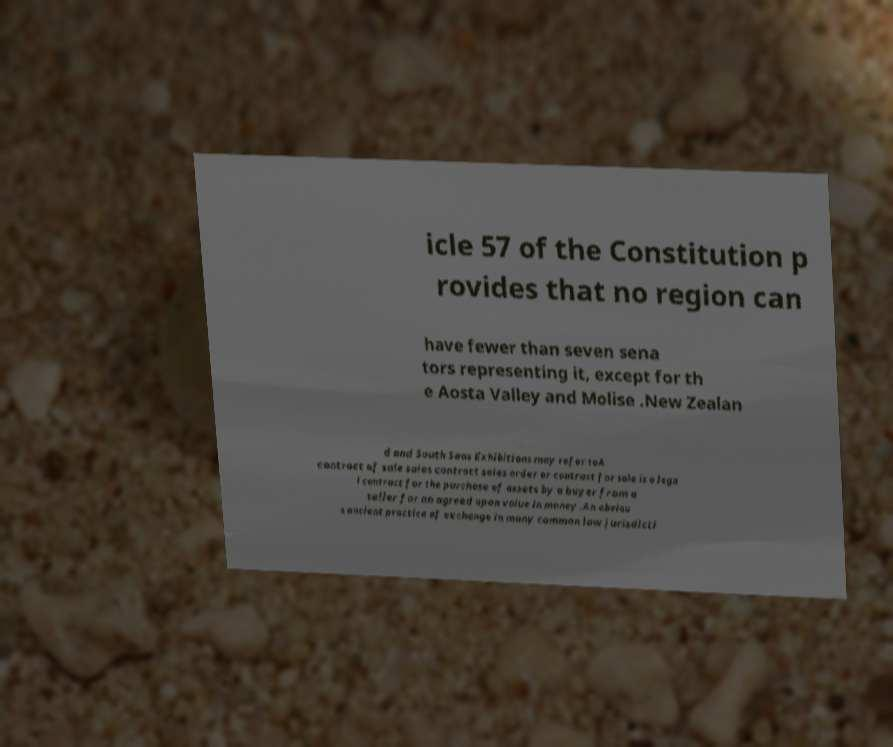There's text embedded in this image that I need extracted. Can you transcribe it verbatim? icle 57 of the Constitution p rovides that no region can have fewer than seven sena tors representing it, except for th e Aosta Valley and Molise .New Zealan d and South Seas Exhibitions may refer toA contract of sale sales contract sales order or contract for sale is a lega l contract for the purchase of assets by a buyer from a seller for an agreed upon value in money .An obviou s ancient practice of exchange in many common law jurisdicti 